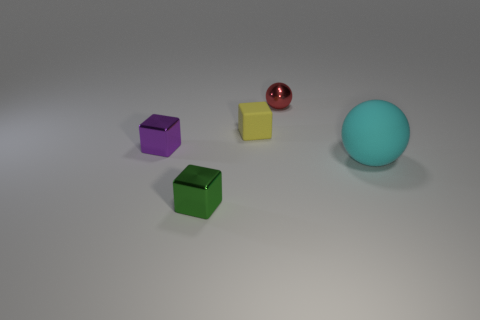Subtract all purple cubes. How many cubes are left? 2 Subtract 1 cubes. How many cubes are left? 2 Subtract all cyan cubes. Subtract all blue cylinders. How many cubes are left? 3 Add 1 metallic things. How many objects exist? 6 Subtract all spheres. How many objects are left? 3 Subtract 0 cyan blocks. How many objects are left? 5 Subtract all big cyan matte balls. Subtract all small yellow blocks. How many objects are left? 3 Add 3 tiny red metallic balls. How many tiny red metallic balls are left? 4 Add 3 small purple things. How many small purple things exist? 4 